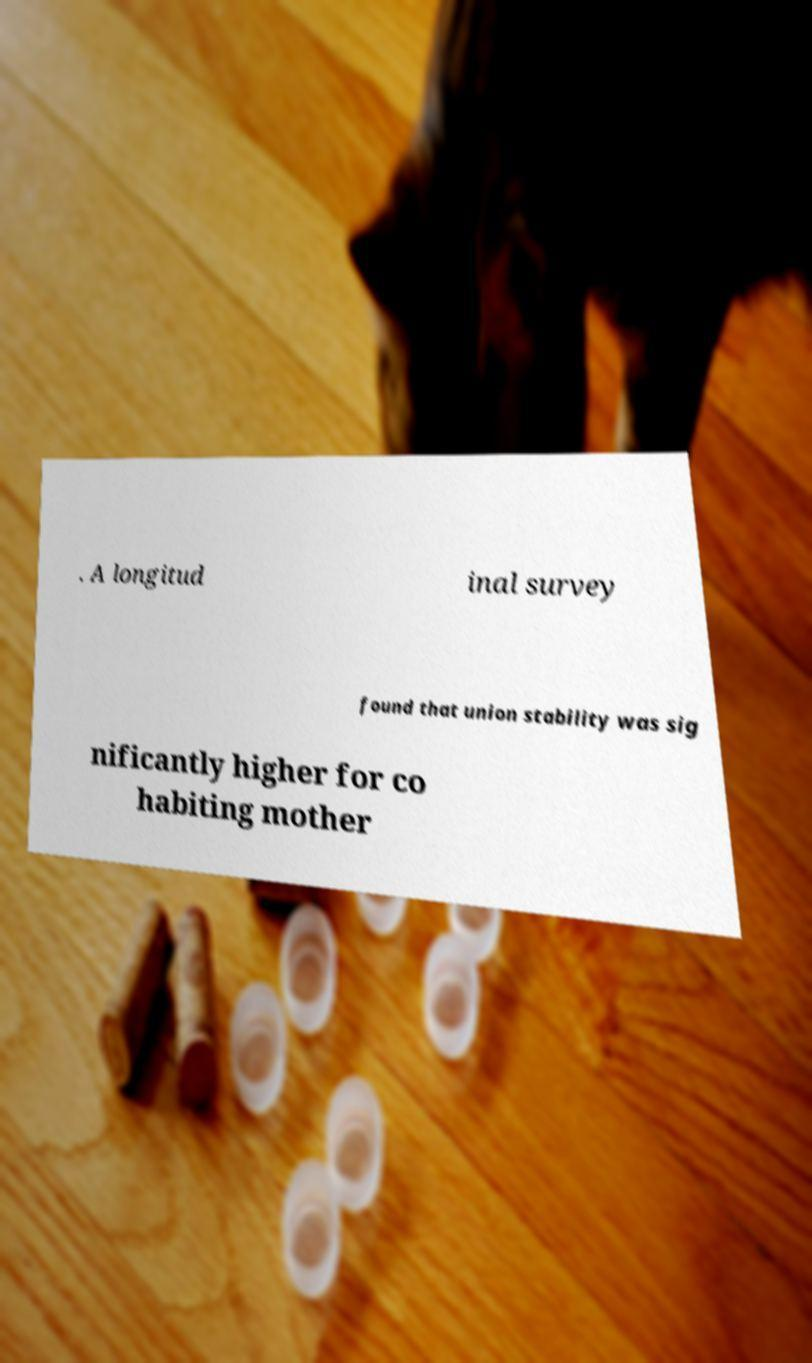There's text embedded in this image that I need extracted. Can you transcribe it verbatim? . A longitud inal survey found that union stability was sig nificantly higher for co habiting mother 